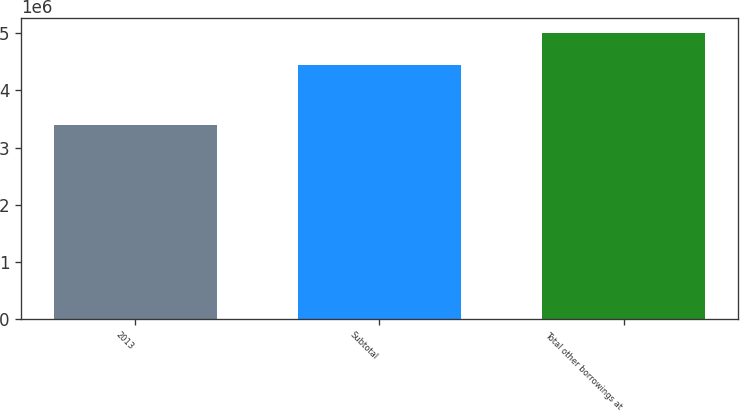<chart> <loc_0><loc_0><loc_500><loc_500><bar_chart><fcel>2013<fcel>Subtotal<fcel>Total other borrowings at<nl><fcel>3.40243e+06<fcel>4.45466e+06<fcel>5.0155e+06<nl></chart> 